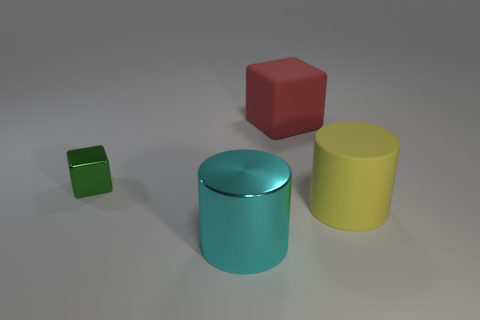What number of other things are there of the same color as the large metal cylinder?
Your answer should be very brief. 0. How many objects are either small metal objects or big cyan matte blocks?
Keep it short and to the point. 1. There is a shiny thing left of the large cyan metal thing; is it the same shape as the big red rubber object?
Offer a terse response. Yes. There is a rubber object behind the block that is in front of the red rubber object; what color is it?
Your answer should be very brief. Red. Is the number of cylinders less than the number of small purple matte things?
Ensure brevity in your answer.  No. Is there a big thing that has the same material as the small green cube?
Your answer should be compact. Yes. There is a tiny metal object; is its shape the same as the metal object in front of the green thing?
Offer a terse response. No. There is a yellow cylinder; are there any big red cubes on the left side of it?
Provide a succinct answer. Yes. What number of big yellow things have the same shape as the large red matte object?
Your answer should be very brief. 0. Do the yellow thing and the cylinder in front of the yellow cylinder have the same material?
Your answer should be very brief. No. 